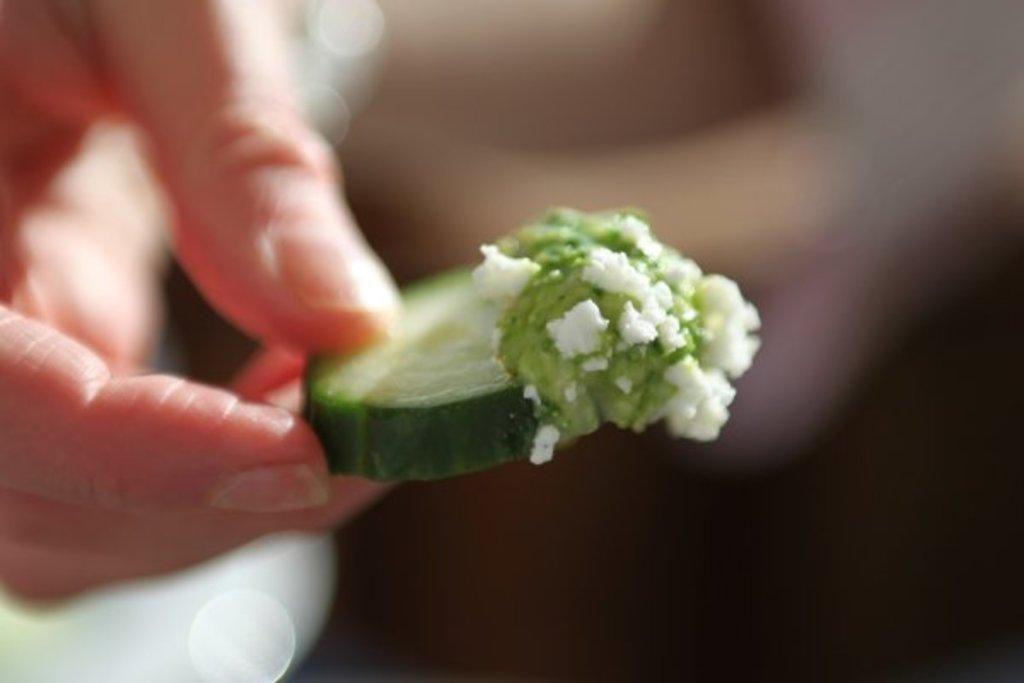What is the hand in the image holding? The hand is holding a food item in the image. Can you describe the background of the image? The background of the image is blurred. What type of hospital can be seen in the background of the image? There is no hospital visible in the image; the background is blurred. How many pizzas are present in the image? There is no information about pizzas in the image; it only shows a hand holding a food item. 